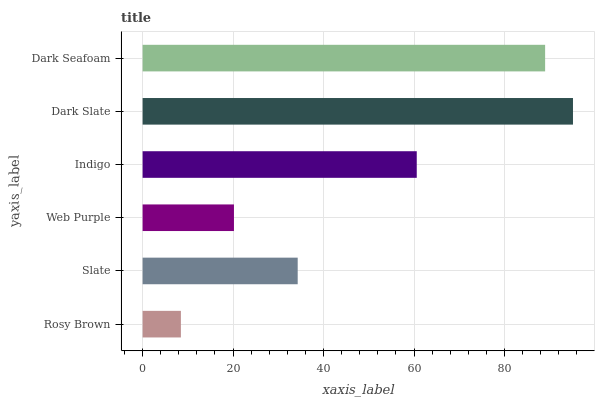Is Rosy Brown the minimum?
Answer yes or no. Yes. Is Dark Slate the maximum?
Answer yes or no. Yes. Is Slate the minimum?
Answer yes or no. No. Is Slate the maximum?
Answer yes or no. No. Is Slate greater than Rosy Brown?
Answer yes or no. Yes. Is Rosy Brown less than Slate?
Answer yes or no. Yes. Is Rosy Brown greater than Slate?
Answer yes or no. No. Is Slate less than Rosy Brown?
Answer yes or no. No. Is Indigo the high median?
Answer yes or no. Yes. Is Slate the low median?
Answer yes or no. Yes. Is Dark Slate the high median?
Answer yes or no. No. Is Dark Slate the low median?
Answer yes or no. No. 